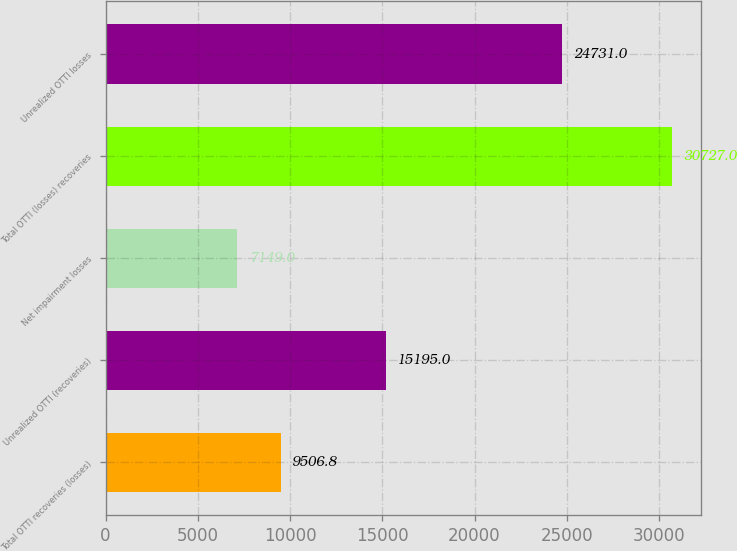<chart> <loc_0><loc_0><loc_500><loc_500><bar_chart><fcel>Total OTTI recoveries (losses)<fcel>Unrealized OTTI (recoveries)<fcel>Net impairment losses<fcel>Total OTTI (losses) recoveries<fcel>Unrealized OTTI losses<nl><fcel>9506.8<fcel>15195<fcel>7149<fcel>30727<fcel>24731<nl></chart> 